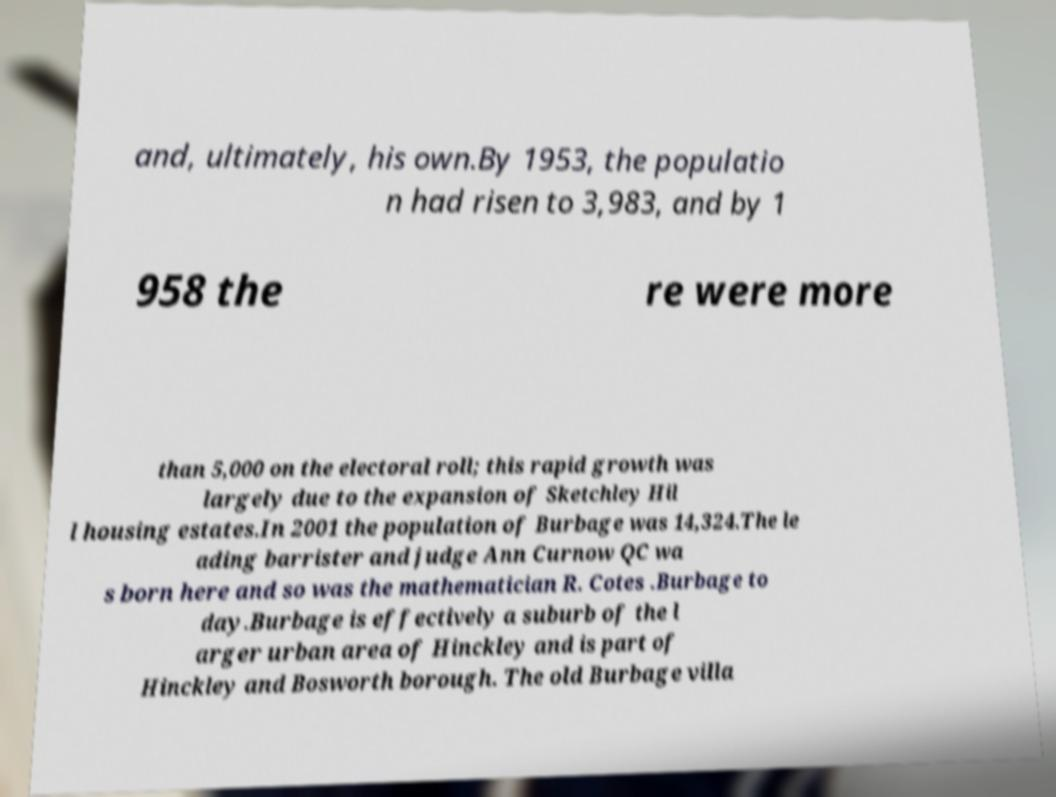Can you accurately transcribe the text from the provided image for me? and, ultimately, his own.By 1953, the populatio n had risen to 3,983, and by 1 958 the re were more than 5,000 on the electoral roll; this rapid growth was largely due to the expansion of Sketchley Hil l housing estates.In 2001 the population of Burbage was 14,324.The le ading barrister and judge Ann Curnow QC wa s born here and so was the mathematician R. Cotes .Burbage to day.Burbage is effectively a suburb of the l arger urban area of Hinckley and is part of Hinckley and Bosworth borough. The old Burbage villa 